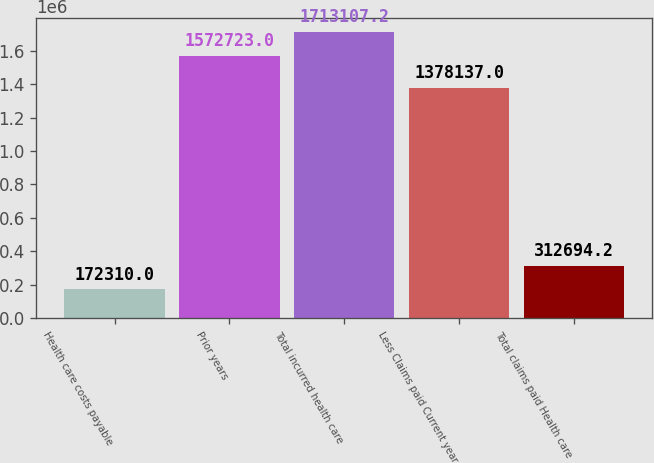Convert chart to OTSL. <chart><loc_0><loc_0><loc_500><loc_500><bar_chart><fcel>Health care costs payable<fcel>Prior years<fcel>Total incurred health care<fcel>Less Claims paid Current year<fcel>Total claims paid Health care<nl><fcel>172310<fcel>1.57272e+06<fcel>1.71311e+06<fcel>1.37814e+06<fcel>312694<nl></chart> 